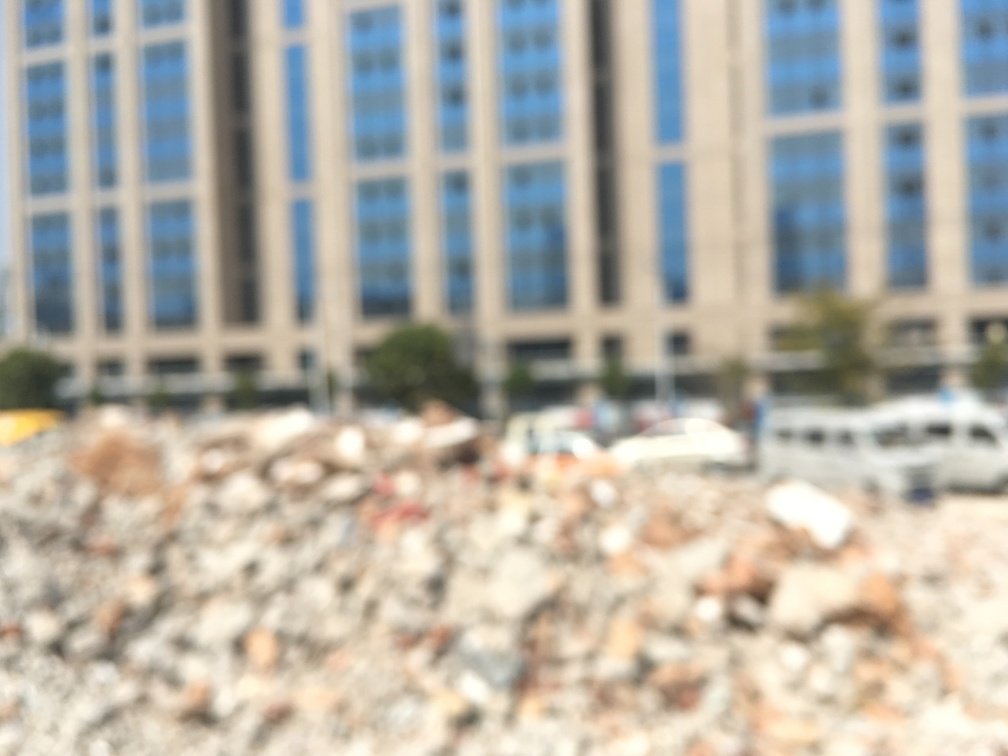Are the buildings and cars clear in the image? Based on the image provided, the clarity of the buildings and cars cannot be adequately assessed due to the significant blur present across the entire image. No details are distinguishable, and the level of clarity is below that which is required to make out specific features or attributes, such as the sharpness of edges or detailed elements of the cars and buildings. 